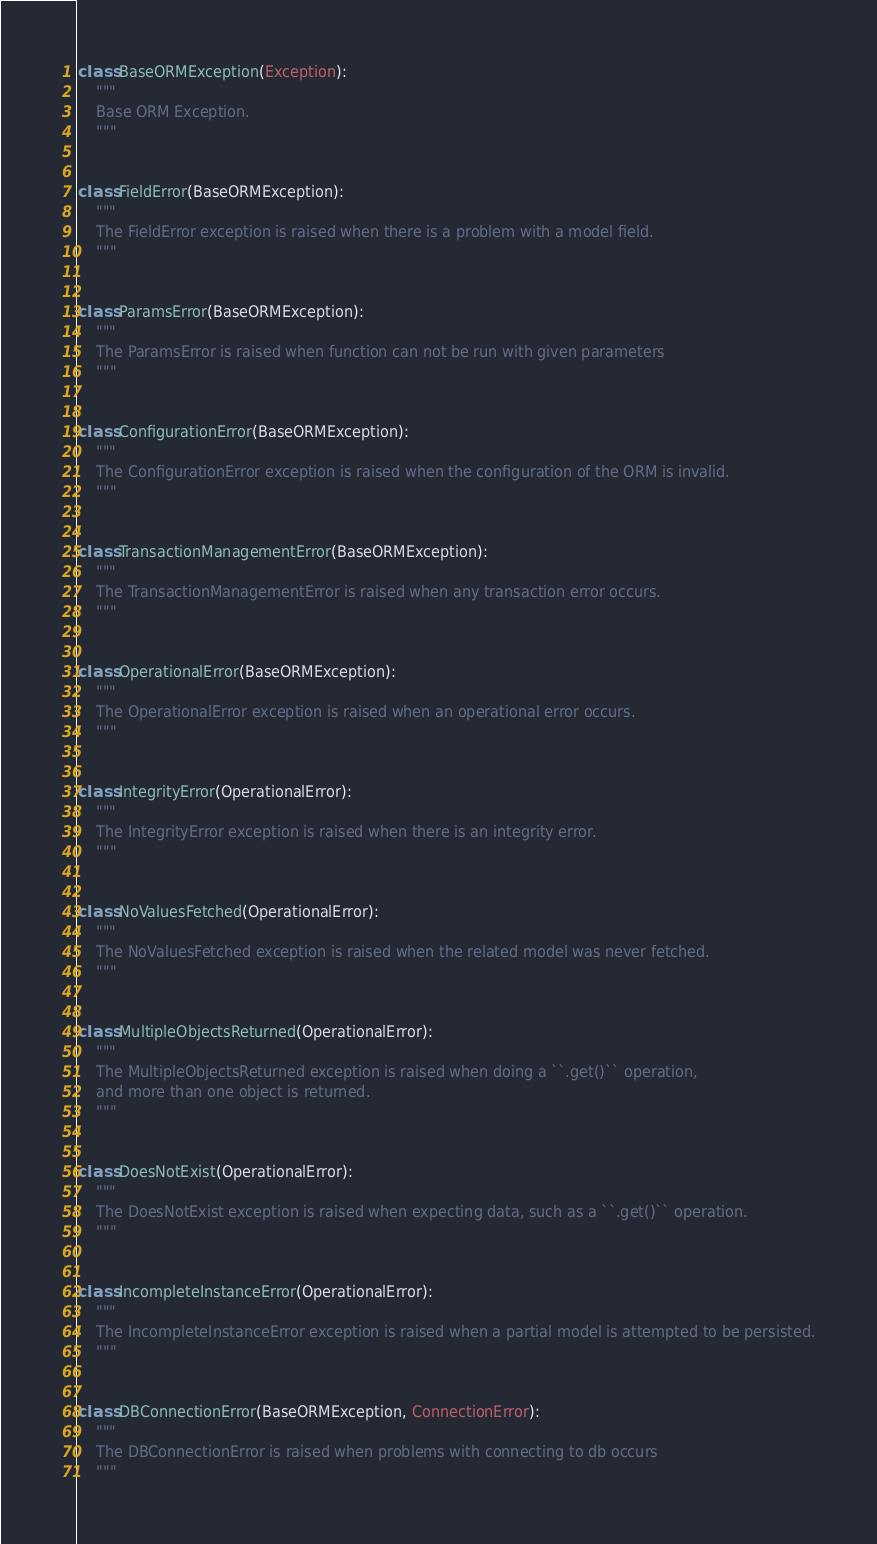Convert code to text. <code><loc_0><loc_0><loc_500><loc_500><_Python_>class BaseORMException(Exception):
    """
    Base ORM Exception.
    """


class FieldError(BaseORMException):
    """
    The FieldError exception is raised when there is a problem with a model field.
    """


class ParamsError(BaseORMException):
    """
    The ParamsError is raised when function can not be run with given parameters
    """


class ConfigurationError(BaseORMException):
    """
    The ConfigurationError exception is raised when the configuration of the ORM is invalid.
    """


class TransactionManagementError(BaseORMException):
    """
    The TransactionManagementError is raised when any transaction error occurs.
    """


class OperationalError(BaseORMException):
    """
    The OperationalError exception is raised when an operational error occurs.
    """


class IntegrityError(OperationalError):
    """
    The IntegrityError exception is raised when there is an integrity error.
    """


class NoValuesFetched(OperationalError):
    """
    The NoValuesFetched exception is raised when the related model was never fetched.
    """


class MultipleObjectsReturned(OperationalError):
    """
    The MultipleObjectsReturned exception is raised when doing a ``.get()`` operation,
    and more than one object is returned.
    """


class DoesNotExist(OperationalError):
    """
    The DoesNotExist exception is raised when expecting data, such as a ``.get()`` operation.
    """


class IncompleteInstanceError(OperationalError):
    """
    The IncompleteInstanceError exception is raised when a partial model is attempted to be persisted.
    """


class DBConnectionError(BaseORMException, ConnectionError):
    """
    The DBConnectionError is raised when problems with connecting to db occurs
    """
</code> 